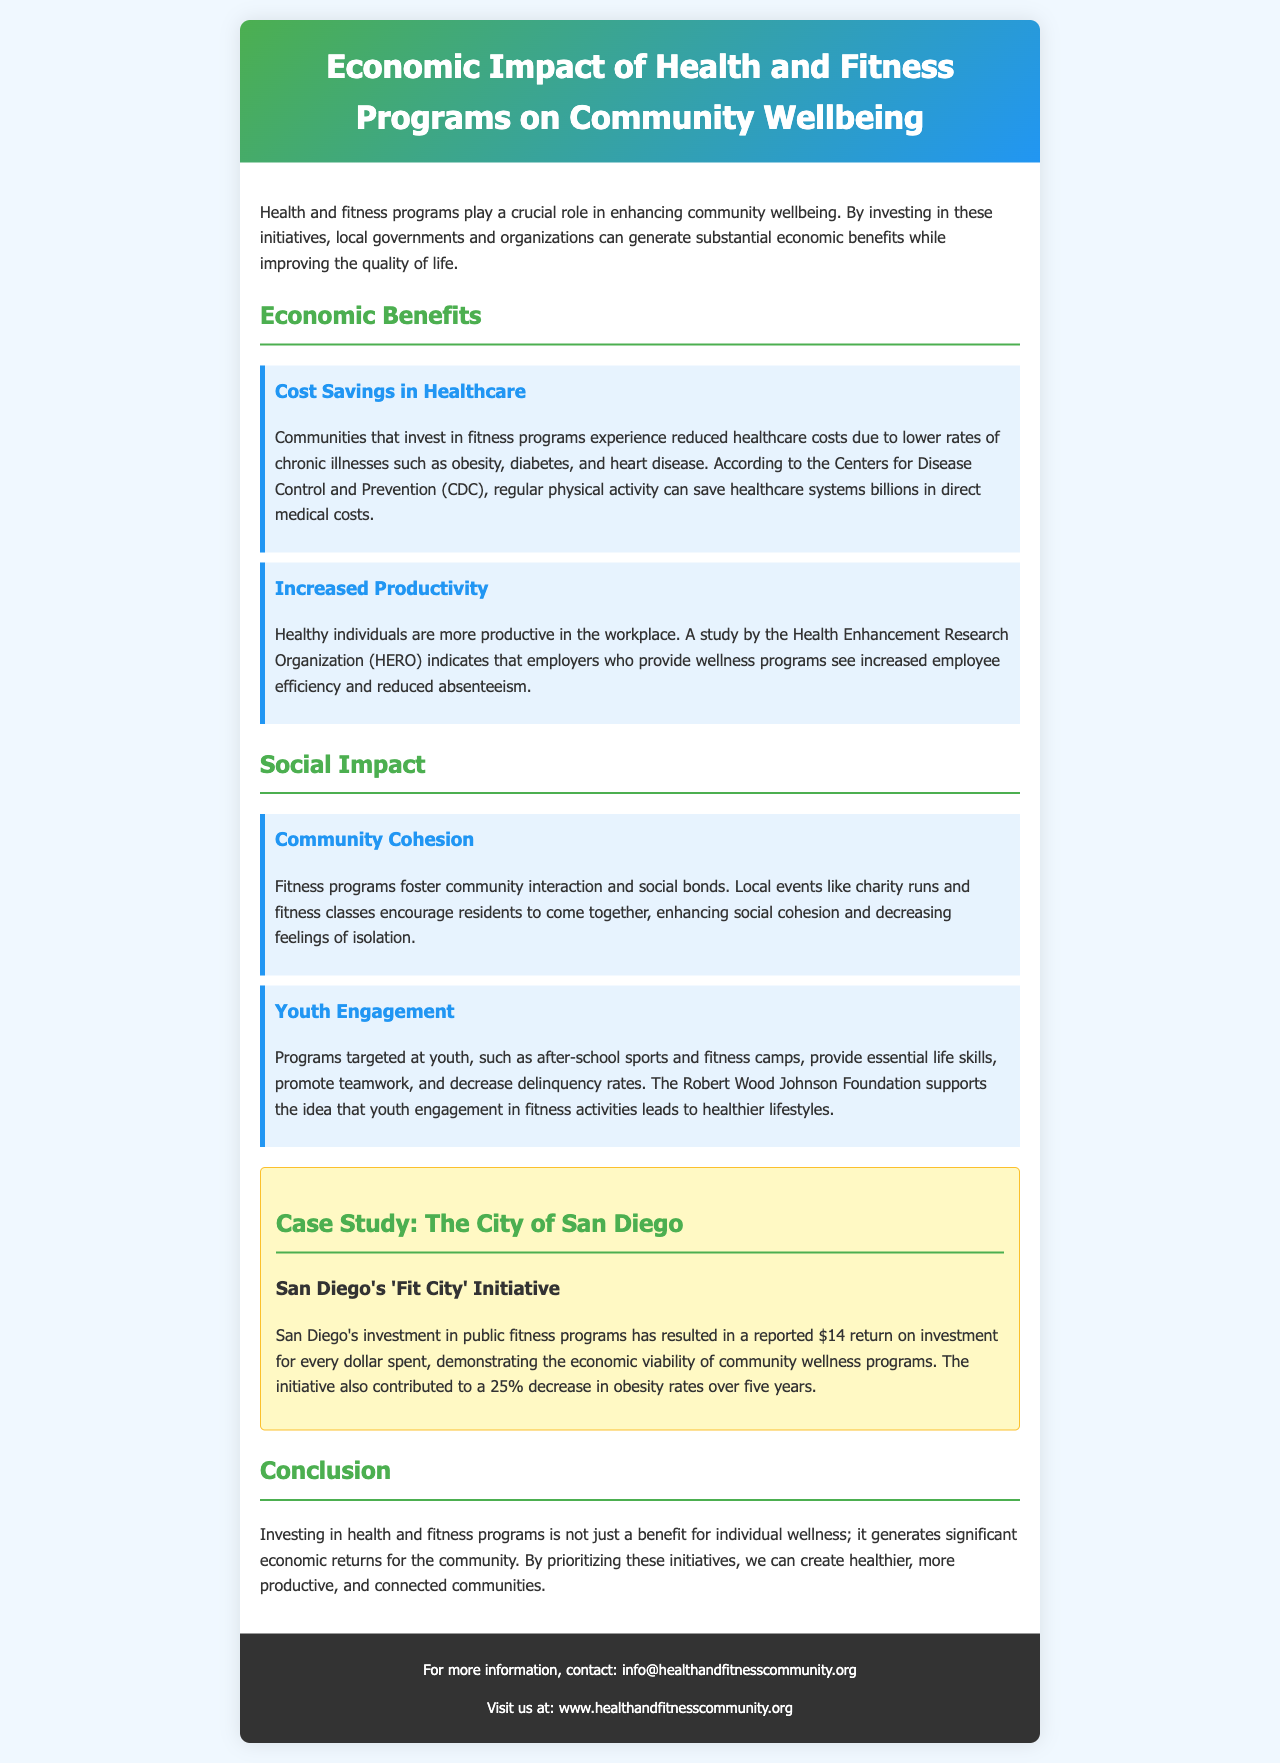What is the title of the brochure? The title of the brochure is provided in the header section, which highlights its main focus on economic impact and community wellbeing.
Answer: Economic Impact of Health and Fitness Programs on Community Wellbeing What organization supports the connection between youth engagement and healthier lifestyles? The document cites the Robert Wood Johnson Foundation in relation to youth engagement and fitness activities.
Answer: Robert Wood Johnson Foundation How much return on investment did San Diego's 'Fit City' Initiative report for every dollar spent? The case study section states the specific return on investment achieved by the San Diego initiative, which exemplifies the economic benefits of community wellness programs.
Answer: $14 What decrease in obesity rates was reported by the City of San Diego over five years? The document mentions a percentage indicating the decline in obesity rates resulting from public fitness programs in San Diego.
Answer: 25% What cost savings can communities experience by investing in fitness programs? The initial understanding of the healthcare savings associated with chronic illness management is clarified through information shared in the economic benefits section.
Answer: Reduced healthcare costs What type of interaction do fitness programs foster in communities? The social impact section illustrates community benefits that arise from participation in health and fitness initiatives.
Answer: Community interaction Which organization indicated that wellness programs could lead to increased employee efficiency? This information is found in the economic benefits section and highlights who conducted the related research on workplace productivity.
Answer: Health Enhancement Research Organization What are two examples of social impacts mentioned in the brochure? The document lists specific areas of community enhancement due to fitness programs, which can be easily found in the social impact section.
Answer: Community cohesion and youth engagement 